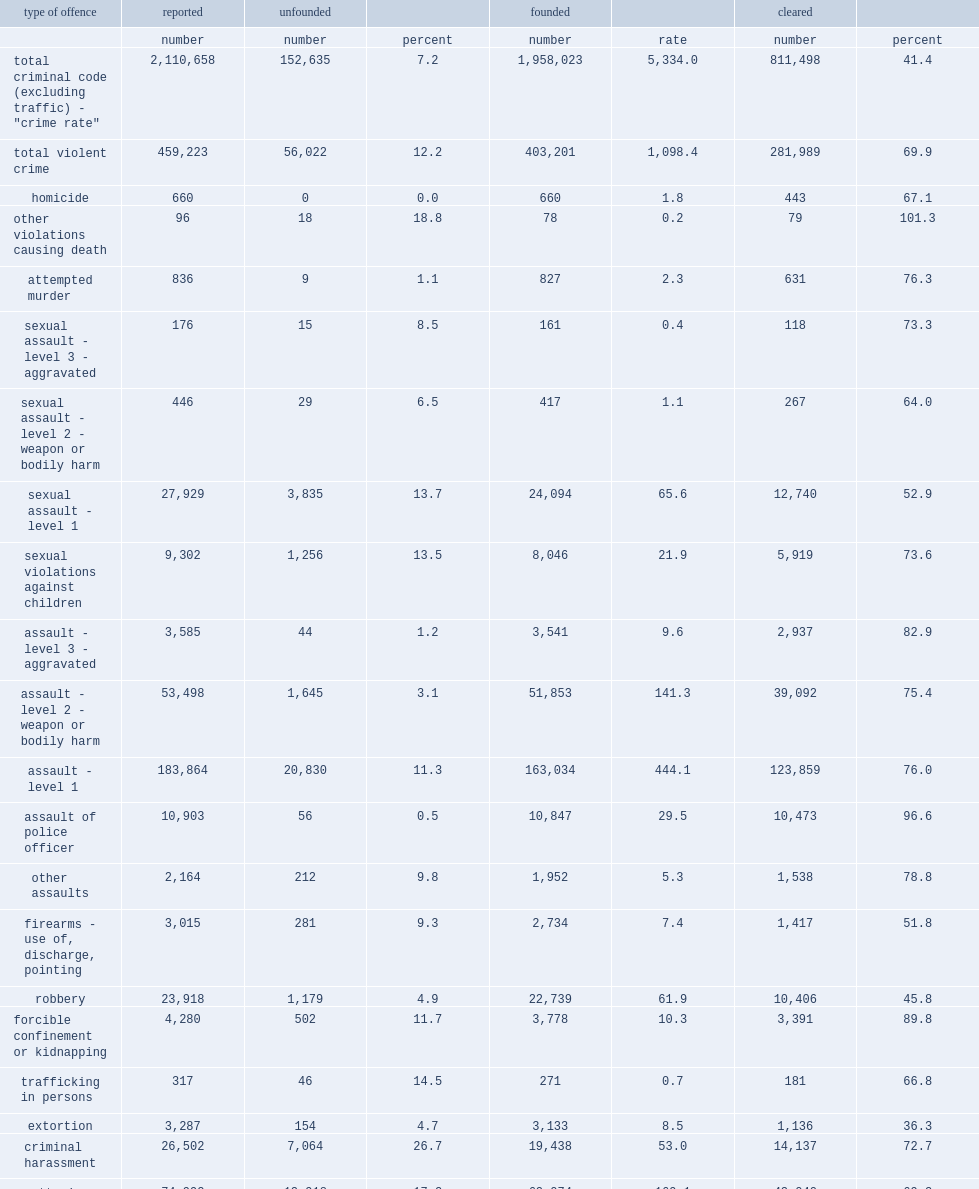What was the percentage of incidents of violent crime that were classified as unfounded? 12.2. What was the percentage of sexual assaults (levels 1, 2 and 3) reported to police classified as unfounded? 13.7. List the top3 offences most likely to be classified as unfounded by police. Criminal harassment indecent or harassing communications uttering threats. What were the percentages of robbery and extortion classified as unfounded? 4.9 4.7. What was the number of incidents of sexual assault reported to police in 2017 that were deemed to be unfounded? 3835.0. What was the percentage of sexual assault representing of all founded incidents of violent crime? 0.059757. 